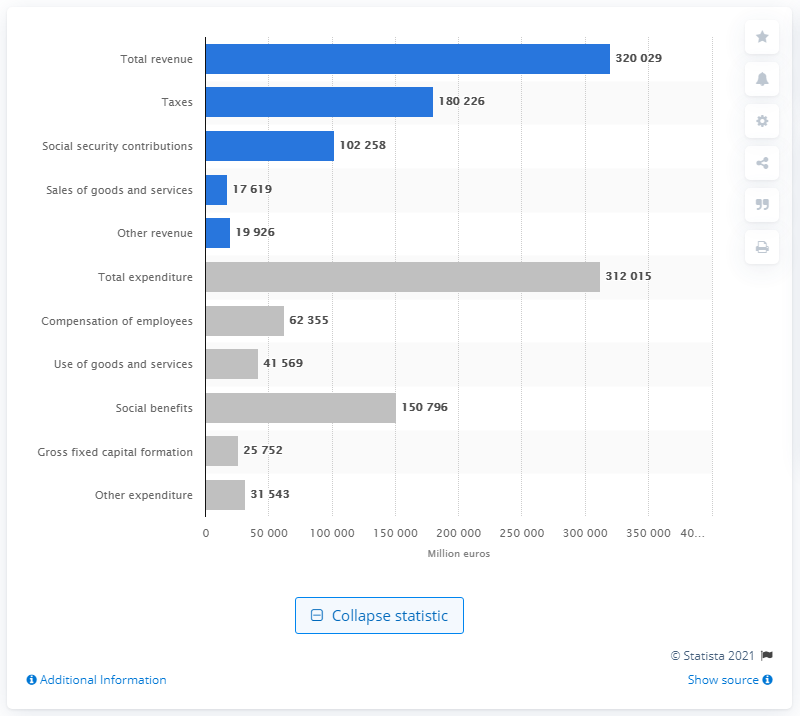Identify some key points in this picture. In 2017, the total expenditure in the Netherlands was 31,201.5. 